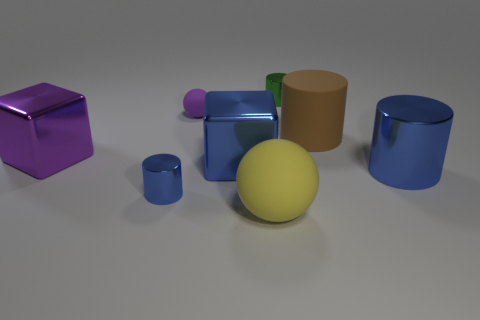There is a big shiny object that is the same color as the tiny matte thing; what shape is it?
Provide a succinct answer. Cube. The metallic block that is the same color as the big metallic cylinder is what size?
Provide a succinct answer. Large. How many other objects are the same shape as the purple metal object?
Provide a short and direct response. 1. Does the small shiny object right of the large rubber ball have the same shape as the large rubber object behind the tiny blue cylinder?
Provide a succinct answer. Yes. Are there the same number of small purple spheres left of the big sphere and cylinders behind the small purple ball?
Provide a succinct answer. Yes. The large metal object that is to the right of the large rubber object right of the cylinder behind the brown object is what shape?
Give a very brief answer. Cylinder. Do the large cylinder that is behind the large blue cylinder and the ball left of the large blue cube have the same material?
Your answer should be very brief. Yes. The tiny shiny thing that is in front of the big brown matte cylinder has what shape?
Make the answer very short. Cylinder. Are there fewer green shiny blocks than small blue things?
Offer a terse response. Yes. There is a cube that is on the right side of the small object in front of the purple cube; are there any big blocks in front of it?
Your response must be concise. No. 